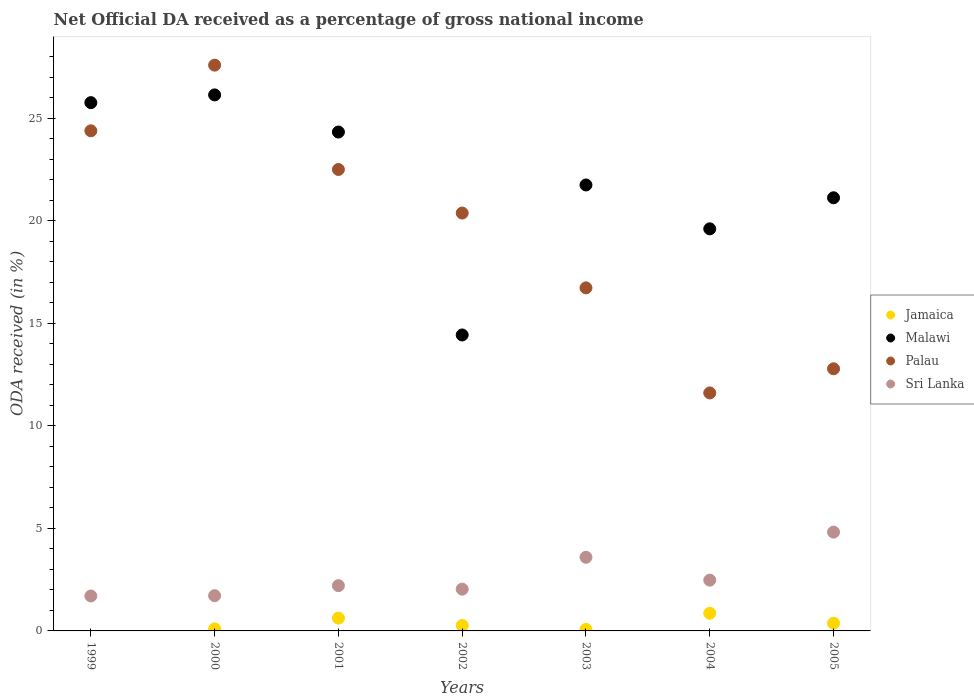How many different coloured dotlines are there?
Offer a terse response. 4. What is the net official DA received in Malawi in 2003?
Your answer should be compact. 21.74. Across all years, what is the maximum net official DA received in Palau?
Offer a very short reply. 27.58. Across all years, what is the minimum net official DA received in Malawi?
Offer a very short reply. 14.43. In which year was the net official DA received in Palau maximum?
Give a very brief answer. 2000. What is the total net official DA received in Palau in the graph?
Your answer should be very brief. 135.94. What is the difference between the net official DA received in Jamaica in 2000 and that in 2004?
Your answer should be compact. -0.76. What is the difference between the net official DA received in Sri Lanka in 2005 and the net official DA received in Palau in 2000?
Offer a very short reply. -22.77. What is the average net official DA received in Jamaica per year?
Your answer should be very brief. 0.33. In the year 2005, what is the difference between the net official DA received in Malawi and net official DA received in Palau?
Your answer should be compact. 8.34. In how many years, is the net official DA received in Jamaica greater than 27 %?
Keep it short and to the point. 0. What is the ratio of the net official DA received in Sri Lanka in 2002 to that in 2004?
Make the answer very short. 0.82. Is the net official DA received in Jamaica in 2001 less than that in 2003?
Make the answer very short. No. Is the difference between the net official DA received in Malawi in 2001 and 2003 greater than the difference between the net official DA received in Palau in 2001 and 2003?
Offer a very short reply. No. What is the difference between the highest and the second highest net official DA received in Palau?
Provide a succinct answer. 3.2. What is the difference between the highest and the lowest net official DA received in Palau?
Ensure brevity in your answer.  15.98. In how many years, is the net official DA received in Sri Lanka greater than the average net official DA received in Sri Lanka taken over all years?
Offer a very short reply. 2. Is it the case that in every year, the sum of the net official DA received in Malawi and net official DA received in Palau  is greater than the net official DA received in Jamaica?
Make the answer very short. Yes. What is the difference between two consecutive major ticks on the Y-axis?
Your response must be concise. 5. Does the graph contain any zero values?
Provide a succinct answer. Yes. Does the graph contain grids?
Give a very brief answer. No. How many legend labels are there?
Keep it short and to the point. 4. What is the title of the graph?
Offer a very short reply. Net Official DA received as a percentage of gross national income. What is the label or title of the Y-axis?
Offer a terse response. ODA received (in %). What is the ODA received (in %) in Malawi in 1999?
Your answer should be very brief. 25.75. What is the ODA received (in %) of Palau in 1999?
Give a very brief answer. 24.38. What is the ODA received (in %) of Sri Lanka in 1999?
Provide a succinct answer. 1.7. What is the ODA received (in %) in Jamaica in 2000?
Offer a terse response. 0.1. What is the ODA received (in %) of Malawi in 2000?
Give a very brief answer. 26.13. What is the ODA received (in %) in Palau in 2000?
Give a very brief answer. 27.58. What is the ODA received (in %) in Sri Lanka in 2000?
Offer a terse response. 1.72. What is the ODA received (in %) of Jamaica in 2001?
Your answer should be compact. 0.63. What is the ODA received (in %) of Malawi in 2001?
Keep it short and to the point. 24.32. What is the ODA received (in %) of Palau in 2001?
Your response must be concise. 22.5. What is the ODA received (in %) of Sri Lanka in 2001?
Make the answer very short. 2.21. What is the ODA received (in %) in Jamaica in 2002?
Your answer should be very brief. 0.26. What is the ODA received (in %) of Malawi in 2002?
Give a very brief answer. 14.43. What is the ODA received (in %) of Palau in 2002?
Offer a very short reply. 20.37. What is the ODA received (in %) of Sri Lanka in 2002?
Make the answer very short. 2.04. What is the ODA received (in %) in Jamaica in 2003?
Offer a very short reply. 0.07. What is the ODA received (in %) of Malawi in 2003?
Make the answer very short. 21.74. What is the ODA received (in %) in Palau in 2003?
Provide a short and direct response. 16.73. What is the ODA received (in %) of Sri Lanka in 2003?
Offer a terse response. 3.59. What is the ODA received (in %) of Jamaica in 2004?
Make the answer very short. 0.86. What is the ODA received (in %) in Malawi in 2004?
Your answer should be compact. 19.6. What is the ODA received (in %) in Palau in 2004?
Your answer should be compact. 11.6. What is the ODA received (in %) of Sri Lanka in 2004?
Make the answer very short. 2.48. What is the ODA received (in %) of Jamaica in 2005?
Keep it short and to the point. 0.38. What is the ODA received (in %) in Malawi in 2005?
Provide a short and direct response. 21.12. What is the ODA received (in %) in Palau in 2005?
Make the answer very short. 12.78. What is the ODA received (in %) in Sri Lanka in 2005?
Keep it short and to the point. 4.82. Across all years, what is the maximum ODA received (in %) in Jamaica?
Your answer should be compact. 0.86. Across all years, what is the maximum ODA received (in %) in Malawi?
Give a very brief answer. 26.13. Across all years, what is the maximum ODA received (in %) in Palau?
Your response must be concise. 27.58. Across all years, what is the maximum ODA received (in %) in Sri Lanka?
Offer a very short reply. 4.82. Across all years, what is the minimum ODA received (in %) of Malawi?
Make the answer very short. 14.43. Across all years, what is the minimum ODA received (in %) in Palau?
Keep it short and to the point. 11.6. Across all years, what is the minimum ODA received (in %) of Sri Lanka?
Provide a short and direct response. 1.7. What is the total ODA received (in %) in Jamaica in the graph?
Provide a short and direct response. 2.3. What is the total ODA received (in %) of Malawi in the graph?
Make the answer very short. 153.1. What is the total ODA received (in %) in Palau in the graph?
Your response must be concise. 135.94. What is the total ODA received (in %) in Sri Lanka in the graph?
Make the answer very short. 18.55. What is the difference between the ODA received (in %) of Malawi in 1999 and that in 2000?
Provide a short and direct response. -0.38. What is the difference between the ODA received (in %) of Palau in 1999 and that in 2000?
Provide a succinct answer. -3.2. What is the difference between the ODA received (in %) of Sri Lanka in 1999 and that in 2000?
Keep it short and to the point. -0.01. What is the difference between the ODA received (in %) of Malawi in 1999 and that in 2001?
Provide a short and direct response. 1.43. What is the difference between the ODA received (in %) of Palau in 1999 and that in 2001?
Your answer should be very brief. 1.89. What is the difference between the ODA received (in %) in Sri Lanka in 1999 and that in 2001?
Your answer should be very brief. -0.5. What is the difference between the ODA received (in %) of Malawi in 1999 and that in 2002?
Keep it short and to the point. 11.33. What is the difference between the ODA received (in %) in Palau in 1999 and that in 2002?
Give a very brief answer. 4.01. What is the difference between the ODA received (in %) of Sri Lanka in 1999 and that in 2002?
Ensure brevity in your answer.  -0.33. What is the difference between the ODA received (in %) of Malawi in 1999 and that in 2003?
Ensure brevity in your answer.  4.01. What is the difference between the ODA received (in %) in Palau in 1999 and that in 2003?
Your response must be concise. 7.66. What is the difference between the ODA received (in %) of Sri Lanka in 1999 and that in 2003?
Provide a succinct answer. -1.89. What is the difference between the ODA received (in %) of Malawi in 1999 and that in 2004?
Your answer should be compact. 6.15. What is the difference between the ODA received (in %) of Palau in 1999 and that in 2004?
Ensure brevity in your answer.  12.78. What is the difference between the ODA received (in %) in Sri Lanka in 1999 and that in 2004?
Your answer should be very brief. -0.77. What is the difference between the ODA received (in %) of Malawi in 1999 and that in 2005?
Ensure brevity in your answer.  4.64. What is the difference between the ODA received (in %) of Palau in 1999 and that in 2005?
Provide a succinct answer. 11.6. What is the difference between the ODA received (in %) of Sri Lanka in 1999 and that in 2005?
Your response must be concise. -3.11. What is the difference between the ODA received (in %) of Jamaica in 2000 and that in 2001?
Offer a very short reply. -0.53. What is the difference between the ODA received (in %) of Malawi in 2000 and that in 2001?
Provide a succinct answer. 1.81. What is the difference between the ODA received (in %) in Palau in 2000 and that in 2001?
Keep it short and to the point. 5.09. What is the difference between the ODA received (in %) of Sri Lanka in 2000 and that in 2001?
Offer a terse response. -0.49. What is the difference between the ODA received (in %) in Jamaica in 2000 and that in 2002?
Your response must be concise. -0.16. What is the difference between the ODA received (in %) in Malawi in 2000 and that in 2002?
Offer a very short reply. 11.7. What is the difference between the ODA received (in %) in Palau in 2000 and that in 2002?
Provide a succinct answer. 7.21. What is the difference between the ODA received (in %) in Sri Lanka in 2000 and that in 2002?
Offer a very short reply. -0.32. What is the difference between the ODA received (in %) in Jamaica in 2000 and that in 2003?
Your answer should be very brief. 0.03. What is the difference between the ODA received (in %) in Malawi in 2000 and that in 2003?
Your answer should be compact. 4.39. What is the difference between the ODA received (in %) in Palau in 2000 and that in 2003?
Your response must be concise. 10.86. What is the difference between the ODA received (in %) of Sri Lanka in 2000 and that in 2003?
Keep it short and to the point. -1.87. What is the difference between the ODA received (in %) of Jamaica in 2000 and that in 2004?
Offer a terse response. -0.76. What is the difference between the ODA received (in %) of Malawi in 2000 and that in 2004?
Make the answer very short. 6.53. What is the difference between the ODA received (in %) of Palau in 2000 and that in 2004?
Provide a succinct answer. 15.98. What is the difference between the ODA received (in %) of Sri Lanka in 2000 and that in 2004?
Your answer should be very brief. -0.76. What is the difference between the ODA received (in %) of Jamaica in 2000 and that in 2005?
Your answer should be compact. -0.28. What is the difference between the ODA received (in %) in Malawi in 2000 and that in 2005?
Provide a short and direct response. 5.02. What is the difference between the ODA received (in %) of Palau in 2000 and that in 2005?
Make the answer very short. 14.8. What is the difference between the ODA received (in %) of Sri Lanka in 2000 and that in 2005?
Ensure brevity in your answer.  -3.1. What is the difference between the ODA received (in %) in Jamaica in 2001 and that in 2002?
Ensure brevity in your answer.  0.36. What is the difference between the ODA received (in %) of Malawi in 2001 and that in 2002?
Provide a short and direct response. 9.89. What is the difference between the ODA received (in %) of Palau in 2001 and that in 2002?
Make the answer very short. 2.12. What is the difference between the ODA received (in %) of Sri Lanka in 2001 and that in 2002?
Offer a terse response. 0.17. What is the difference between the ODA received (in %) in Jamaica in 2001 and that in 2003?
Provide a short and direct response. 0.55. What is the difference between the ODA received (in %) of Malawi in 2001 and that in 2003?
Make the answer very short. 2.58. What is the difference between the ODA received (in %) in Palau in 2001 and that in 2003?
Your answer should be compact. 5.77. What is the difference between the ODA received (in %) in Sri Lanka in 2001 and that in 2003?
Offer a very short reply. -1.38. What is the difference between the ODA received (in %) in Jamaica in 2001 and that in 2004?
Your answer should be very brief. -0.24. What is the difference between the ODA received (in %) in Malawi in 2001 and that in 2004?
Give a very brief answer. 4.72. What is the difference between the ODA received (in %) of Palau in 2001 and that in 2004?
Give a very brief answer. 10.89. What is the difference between the ODA received (in %) of Sri Lanka in 2001 and that in 2004?
Offer a terse response. -0.27. What is the difference between the ODA received (in %) in Jamaica in 2001 and that in 2005?
Your answer should be compact. 0.25. What is the difference between the ODA received (in %) of Malawi in 2001 and that in 2005?
Keep it short and to the point. 3.21. What is the difference between the ODA received (in %) in Palau in 2001 and that in 2005?
Keep it short and to the point. 9.72. What is the difference between the ODA received (in %) in Sri Lanka in 2001 and that in 2005?
Your response must be concise. -2.61. What is the difference between the ODA received (in %) of Jamaica in 2002 and that in 2003?
Your response must be concise. 0.19. What is the difference between the ODA received (in %) of Malawi in 2002 and that in 2003?
Provide a succinct answer. -7.31. What is the difference between the ODA received (in %) in Palau in 2002 and that in 2003?
Offer a terse response. 3.65. What is the difference between the ODA received (in %) of Sri Lanka in 2002 and that in 2003?
Your answer should be very brief. -1.55. What is the difference between the ODA received (in %) in Jamaica in 2002 and that in 2004?
Provide a succinct answer. -0.6. What is the difference between the ODA received (in %) of Malawi in 2002 and that in 2004?
Make the answer very short. -5.17. What is the difference between the ODA received (in %) in Palau in 2002 and that in 2004?
Provide a short and direct response. 8.77. What is the difference between the ODA received (in %) in Sri Lanka in 2002 and that in 2004?
Provide a short and direct response. -0.44. What is the difference between the ODA received (in %) of Jamaica in 2002 and that in 2005?
Your answer should be very brief. -0.11. What is the difference between the ODA received (in %) in Malawi in 2002 and that in 2005?
Offer a very short reply. -6.69. What is the difference between the ODA received (in %) of Palau in 2002 and that in 2005?
Your response must be concise. 7.59. What is the difference between the ODA received (in %) of Sri Lanka in 2002 and that in 2005?
Your response must be concise. -2.78. What is the difference between the ODA received (in %) of Jamaica in 2003 and that in 2004?
Ensure brevity in your answer.  -0.79. What is the difference between the ODA received (in %) of Malawi in 2003 and that in 2004?
Your answer should be compact. 2.14. What is the difference between the ODA received (in %) in Palau in 2003 and that in 2004?
Make the answer very short. 5.12. What is the difference between the ODA received (in %) of Sri Lanka in 2003 and that in 2004?
Keep it short and to the point. 1.11. What is the difference between the ODA received (in %) in Jamaica in 2003 and that in 2005?
Provide a succinct answer. -0.3. What is the difference between the ODA received (in %) in Malawi in 2003 and that in 2005?
Your answer should be very brief. 0.62. What is the difference between the ODA received (in %) in Palau in 2003 and that in 2005?
Offer a very short reply. 3.95. What is the difference between the ODA received (in %) of Sri Lanka in 2003 and that in 2005?
Give a very brief answer. -1.23. What is the difference between the ODA received (in %) of Jamaica in 2004 and that in 2005?
Provide a short and direct response. 0.49. What is the difference between the ODA received (in %) in Malawi in 2004 and that in 2005?
Your response must be concise. -1.51. What is the difference between the ODA received (in %) in Palau in 2004 and that in 2005?
Your answer should be very brief. -1.18. What is the difference between the ODA received (in %) of Sri Lanka in 2004 and that in 2005?
Make the answer very short. -2.34. What is the difference between the ODA received (in %) in Malawi in 1999 and the ODA received (in %) in Palau in 2000?
Offer a very short reply. -1.83. What is the difference between the ODA received (in %) of Malawi in 1999 and the ODA received (in %) of Sri Lanka in 2000?
Your answer should be compact. 24.04. What is the difference between the ODA received (in %) in Palau in 1999 and the ODA received (in %) in Sri Lanka in 2000?
Keep it short and to the point. 22.66. What is the difference between the ODA received (in %) of Malawi in 1999 and the ODA received (in %) of Palau in 2001?
Provide a succinct answer. 3.26. What is the difference between the ODA received (in %) of Malawi in 1999 and the ODA received (in %) of Sri Lanka in 2001?
Your response must be concise. 23.55. What is the difference between the ODA received (in %) of Palau in 1999 and the ODA received (in %) of Sri Lanka in 2001?
Give a very brief answer. 22.17. What is the difference between the ODA received (in %) in Malawi in 1999 and the ODA received (in %) in Palau in 2002?
Offer a very short reply. 5.38. What is the difference between the ODA received (in %) of Malawi in 1999 and the ODA received (in %) of Sri Lanka in 2002?
Your answer should be compact. 23.72. What is the difference between the ODA received (in %) of Palau in 1999 and the ODA received (in %) of Sri Lanka in 2002?
Keep it short and to the point. 22.35. What is the difference between the ODA received (in %) in Malawi in 1999 and the ODA received (in %) in Palau in 2003?
Give a very brief answer. 9.03. What is the difference between the ODA received (in %) of Malawi in 1999 and the ODA received (in %) of Sri Lanka in 2003?
Offer a very short reply. 22.16. What is the difference between the ODA received (in %) in Palau in 1999 and the ODA received (in %) in Sri Lanka in 2003?
Ensure brevity in your answer.  20.79. What is the difference between the ODA received (in %) in Malawi in 1999 and the ODA received (in %) in Palau in 2004?
Make the answer very short. 14.15. What is the difference between the ODA received (in %) of Malawi in 1999 and the ODA received (in %) of Sri Lanka in 2004?
Your response must be concise. 23.28. What is the difference between the ODA received (in %) of Palau in 1999 and the ODA received (in %) of Sri Lanka in 2004?
Give a very brief answer. 21.91. What is the difference between the ODA received (in %) of Malawi in 1999 and the ODA received (in %) of Palau in 2005?
Offer a very short reply. 12.97. What is the difference between the ODA received (in %) of Malawi in 1999 and the ODA received (in %) of Sri Lanka in 2005?
Provide a short and direct response. 20.94. What is the difference between the ODA received (in %) in Palau in 1999 and the ODA received (in %) in Sri Lanka in 2005?
Give a very brief answer. 19.57. What is the difference between the ODA received (in %) in Jamaica in 2000 and the ODA received (in %) in Malawi in 2001?
Offer a very short reply. -24.22. What is the difference between the ODA received (in %) of Jamaica in 2000 and the ODA received (in %) of Palau in 2001?
Ensure brevity in your answer.  -22.4. What is the difference between the ODA received (in %) of Jamaica in 2000 and the ODA received (in %) of Sri Lanka in 2001?
Your response must be concise. -2.11. What is the difference between the ODA received (in %) of Malawi in 2000 and the ODA received (in %) of Palau in 2001?
Keep it short and to the point. 3.64. What is the difference between the ODA received (in %) of Malawi in 2000 and the ODA received (in %) of Sri Lanka in 2001?
Give a very brief answer. 23.92. What is the difference between the ODA received (in %) of Palau in 2000 and the ODA received (in %) of Sri Lanka in 2001?
Offer a very short reply. 25.38. What is the difference between the ODA received (in %) of Jamaica in 2000 and the ODA received (in %) of Malawi in 2002?
Keep it short and to the point. -14.33. What is the difference between the ODA received (in %) in Jamaica in 2000 and the ODA received (in %) in Palau in 2002?
Offer a terse response. -20.27. What is the difference between the ODA received (in %) in Jamaica in 2000 and the ODA received (in %) in Sri Lanka in 2002?
Provide a succinct answer. -1.94. What is the difference between the ODA received (in %) in Malawi in 2000 and the ODA received (in %) in Palau in 2002?
Provide a succinct answer. 5.76. What is the difference between the ODA received (in %) of Malawi in 2000 and the ODA received (in %) of Sri Lanka in 2002?
Provide a short and direct response. 24.1. What is the difference between the ODA received (in %) in Palau in 2000 and the ODA received (in %) in Sri Lanka in 2002?
Ensure brevity in your answer.  25.55. What is the difference between the ODA received (in %) of Jamaica in 2000 and the ODA received (in %) of Malawi in 2003?
Your answer should be very brief. -21.64. What is the difference between the ODA received (in %) in Jamaica in 2000 and the ODA received (in %) in Palau in 2003?
Give a very brief answer. -16.63. What is the difference between the ODA received (in %) of Jamaica in 2000 and the ODA received (in %) of Sri Lanka in 2003?
Provide a short and direct response. -3.49. What is the difference between the ODA received (in %) in Malawi in 2000 and the ODA received (in %) in Palau in 2003?
Provide a succinct answer. 9.41. What is the difference between the ODA received (in %) of Malawi in 2000 and the ODA received (in %) of Sri Lanka in 2003?
Give a very brief answer. 22.54. What is the difference between the ODA received (in %) of Palau in 2000 and the ODA received (in %) of Sri Lanka in 2003?
Provide a succinct answer. 23.99. What is the difference between the ODA received (in %) of Jamaica in 2000 and the ODA received (in %) of Malawi in 2004?
Ensure brevity in your answer.  -19.5. What is the difference between the ODA received (in %) in Jamaica in 2000 and the ODA received (in %) in Palau in 2004?
Give a very brief answer. -11.5. What is the difference between the ODA received (in %) in Jamaica in 2000 and the ODA received (in %) in Sri Lanka in 2004?
Offer a very short reply. -2.38. What is the difference between the ODA received (in %) of Malawi in 2000 and the ODA received (in %) of Palau in 2004?
Your answer should be very brief. 14.53. What is the difference between the ODA received (in %) of Malawi in 2000 and the ODA received (in %) of Sri Lanka in 2004?
Give a very brief answer. 23.66. What is the difference between the ODA received (in %) in Palau in 2000 and the ODA received (in %) in Sri Lanka in 2004?
Your answer should be very brief. 25.11. What is the difference between the ODA received (in %) of Jamaica in 2000 and the ODA received (in %) of Malawi in 2005?
Provide a succinct answer. -21.02. What is the difference between the ODA received (in %) in Jamaica in 2000 and the ODA received (in %) in Palau in 2005?
Make the answer very short. -12.68. What is the difference between the ODA received (in %) in Jamaica in 2000 and the ODA received (in %) in Sri Lanka in 2005?
Your response must be concise. -4.72. What is the difference between the ODA received (in %) of Malawi in 2000 and the ODA received (in %) of Palau in 2005?
Your response must be concise. 13.35. What is the difference between the ODA received (in %) of Malawi in 2000 and the ODA received (in %) of Sri Lanka in 2005?
Ensure brevity in your answer.  21.32. What is the difference between the ODA received (in %) in Palau in 2000 and the ODA received (in %) in Sri Lanka in 2005?
Ensure brevity in your answer.  22.77. What is the difference between the ODA received (in %) in Jamaica in 2001 and the ODA received (in %) in Malawi in 2002?
Offer a very short reply. -13.8. What is the difference between the ODA received (in %) in Jamaica in 2001 and the ODA received (in %) in Palau in 2002?
Provide a short and direct response. -19.75. What is the difference between the ODA received (in %) of Jamaica in 2001 and the ODA received (in %) of Sri Lanka in 2002?
Your answer should be very brief. -1.41. What is the difference between the ODA received (in %) of Malawi in 2001 and the ODA received (in %) of Palau in 2002?
Offer a terse response. 3.95. What is the difference between the ODA received (in %) of Malawi in 2001 and the ODA received (in %) of Sri Lanka in 2002?
Provide a short and direct response. 22.29. What is the difference between the ODA received (in %) of Palau in 2001 and the ODA received (in %) of Sri Lanka in 2002?
Make the answer very short. 20.46. What is the difference between the ODA received (in %) of Jamaica in 2001 and the ODA received (in %) of Malawi in 2003?
Keep it short and to the point. -21.12. What is the difference between the ODA received (in %) in Jamaica in 2001 and the ODA received (in %) in Palau in 2003?
Your answer should be compact. -16.1. What is the difference between the ODA received (in %) in Jamaica in 2001 and the ODA received (in %) in Sri Lanka in 2003?
Your answer should be very brief. -2.97. What is the difference between the ODA received (in %) in Malawi in 2001 and the ODA received (in %) in Palau in 2003?
Offer a very short reply. 7.6. What is the difference between the ODA received (in %) in Malawi in 2001 and the ODA received (in %) in Sri Lanka in 2003?
Your answer should be very brief. 20.73. What is the difference between the ODA received (in %) of Palau in 2001 and the ODA received (in %) of Sri Lanka in 2003?
Make the answer very short. 18.91. What is the difference between the ODA received (in %) in Jamaica in 2001 and the ODA received (in %) in Malawi in 2004?
Ensure brevity in your answer.  -18.98. What is the difference between the ODA received (in %) in Jamaica in 2001 and the ODA received (in %) in Palau in 2004?
Provide a succinct answer. -10.98. What is the difference between the ODA received (in %) in Jamaica in 2001 and the ODA received (in %) in Sri Lanka in 2004?
Your answer should be compact. -1.85. What is the difference between the ODA received (in %) of Malawi in 2001 and the ODA received (in %) of Palau in 2004?
Your response must be concise. 12.72. What is the difference between the ODA received (in %) in Malawi in 2001 and the ODA received (in %) in Sri Lanka in 2004?
Ensure brevity in your answer.  21.85. What is the difference between the ODA received (in %) of Palau in 2001 and the ODA received (in %) of Sri Lanka in 2004?
Provide a short and direct response. 20.02. What is the difference between the ODA received (in %) in Jamaica in 2001 and the ODA received (in %) in Malawi in 2005?
Make the answer very short. -20.49. What is the difference between the ODA received (in %) of Jamaica in 2001 and the ODA received (in %) of Palau in 2005?
Provide a short and direct response. -12.15. What is the difference between the ODA received (in %) of Jamaica in 2001 and the ODA received (in %) of Sri Lanka in 2005?
Your answer should be very brief. -4.19. What is the difference between the ODA received (in %) of Malawi in 2001 and the ODA received (in %) of Palau in 2005?
Keep it short and to the point. 11.54. What is the difference between the ODA received (in %) in Malawi in 2001 and the ODA received (in %) in Sri Lanka in 2005?
Offer a very short reply. 19.51. What is the difference between the ODA received (in %) of Palau in 2001 and the ODA received (in %) of Sri Lanka in 2005?
Offer a very short reply. 17.68. What is the difference between the ODA received (in %) in Jamaica in 2002 and the ODA received (in %) in Malawi in 2003?
Offer a very short reply. -21.48. What is the difference between the ODA received (in %) in Jamaica in 2002 and the ODA received (in %) in Palau in 2003?
Give a very brief answer. -16.46. What is the difference between the ODA received (in %) in Jamaica in 2002 and the ODA received (in %) in Sri Lanka in 2003?
Ensure brevity in your answer.  -3.33. What is the difference between the ODA received (in %) of Malawi in 2002 and the ODA received (in %) of Palau in 2003?
Offer a terse response. -2.3. What is the difference between the ODA received (in %) in Malawi in 2002 and the ODA received (in %) in Sri Lanka in 2003?
Offer a very short reply. 10.84. What is the difference between the ODA received (in %) in Palau in 2002 and the ODA received (in %) in Sri Lanka in 2003?
Offer a terse response. 16.78. What is the difference between the ODA received (in %) of Jamaica in 2002 and the ODA received (in %) of Malawi in 2004?
Your answer should be very brief. -19.34. What is the difference between the ODA received (in %) in Jamaica in 2002 and the ODA received (in %) in Palau in 2004?
Offer a very short reply. -11.34. What is the difference between the ODA received (in %) in Jamaica in 2002 and the ODA received (in %) in Sri Lanka in 2004?
Your answer should be very brief. -2.21. What is the difference between the ODA received (in %) of Malawi in 2002 and the ODA received (in %) of Palau in 2004?
Make the answer very short. 2.83. What is the difference between the ODA received (in %) of Malawi in 2002 and the ODA received (in %) of Sri Lanka in 2004?
Provide a short and direct response. 11.95. What is the difference between the ODA received (in %) in Palau in 2002 and the ODA received (in %) in Sri Lanka in 2004?
Give a very brief answer. 17.9. What is the difference between the ODA received (in %) of Jamaica in 2002 and the ODA received (in %) of Malawi in 2005?
Provide a short and direct response. -20.85. What is the difference between the ODA received (in %) of Jamaica in 2002 and the ODA received (in %) of Palau in 2005?
Provide a short and direct response. -12.52. What is the difference between the ODA received (in %) in Jamaica in 2002 and the ODA received (in %) in Sri Lanka in 2005?
Offer a terse response. -4.55. What is the difference between the ODA received (in %) in Malawi in 2002 and the ODA received (in %) in Palau in 2005?
Provide a succinct answer. 1.65. What is the difference between the ODA received (in %) in Malawi in 2002 and the ODA received (in %) in Sri Lanka in 2005?
Provide a short and direct response. 9.61. What is the difference between the ODA received (in %) in Palau in 2002 and the ODA received (in %) in Sri Lanka in 2005?
Provide a succinct answer. 15.56. What is the difference between the ODA received (in %) of Jamaica in 2003 and the ODA received (in %) of Malawi in 2004?
Offer a very short reply. -19.53. What is the difference between the ODA received (in %) of Jamaica in 2003 and the ODA received (in %) of Palau in 2004?
Keep it short and to the point. -11.53. What is the difference between the ODA received (in %) in Jamaica in 2003 and the ODA received (in %) in Sri Lanka in 2004?
Offer a terse response. -2.4. What is the difference between the ODA received (in %) of Malawi in 2003 and the ODA received (in %) of Palau in 2004?
Keep it short and to the point. 10.14. What is the difference between the ODA received (in %) in Malawi in 2003 and the ODA received (in %) in Sri Lanka in 2004?
Offer a terse response. 19.27. What is the difference between the ODA received (in %) in Palau in 2003 and the ODA received (in %) in Sri Lanka in 2004?
Offer a terse response. 14.25. What is the difference between the ODA received (in %) in Jamaica in 2003 and the ODA received (in %) in Malawi in 2005?
Make the answer very short. -21.04. What is the difference between the ODA received (in %) of Jamaica in 2003 and the ODA received (in %) of Palau in 2005?
Ensure brevity in your answer.  -12.71. What is the difference between the ODA received (in %) of Jamaica in 2003 and the ODA received (in %) of Sri Lanka in 2005?
Offer a terse response. -4.74. What is the difference between the ODA received (in %) in Malawi in 2003 and the ODA received (in %) in Palau in 2005?
Give a very brief answer. 8.96. What is the difference between the ODA received (in %) of Malawi in 2003 and the ODA received (in %) of Sri Lanka in 2005?
Ensure brevity in your answer.  16.92. What is the difference between the ODA received (in %) of Palau in 2003 and the ODA received (in %) of Sri Lanka in 2005?
Give a very brief answer. 11.91. What is the difference between the ODA received (in %) of Jamaica in 2004 and the ODA received (in %) of Malawi in 2005?
Provide a succinct answer. -20.25. What is the difference between the ODA received (in %) of Jamaica in 2004 and the ODA received (in %) of Palau in 2005?
Your answer should be compact. -11.92. What is the difference between the ODA received (in %) in Jamaica in 2004 and the ODA received (in %) in Sri Lanka in 2005?
Give a very brief answer. -3.95. What is the difference between the ODA received (in %) of Malawi in 2004 and the ODA received (in %) of Palau in 2005?
Your response must be concise. 6.82. What is the difference between the ODA received (in %) in Malawi in 2004 and the ODA received (in %) in Sri Lanka in 2005?
Your answer should be compact. 14.79. What is the difference between the ODA received (in %) of Palau in 2004 and the ODA received (in %) of Sri Lanka in 2005?
Provide a succinct answer. 6.79. What is the average ODA received (in %) of Jamaica per year?
Make the answer very short. 0.33. What is the average ODA received (in %) of Malawi per year?
Your answer should be very brief. 21.87. What is the average ODA received (in %) of Palau per year?
Offer a terse response. 19.42. What is the average ODA received (in %) of Sri Lanka per year?
Keep it short and to the point. 2.65. In the year 1999, what is the difference between the ODA received (in %) of Malawi and ODA received (in %) of Palau?
Ensure brevity in your answer.  1.37. In the year 1999, what is the difference between the ODA received (in %) in Malawi and ODA received (in %) in Sri Lanka?
Keep it short and to the point. 24.05. In the year 1999, what is the difference between the ODA received (in %) of Palau and ODA received (in %) of Sri Lanka?
Ensure brevity in your answer.  22.68. In the year 2000, what is the difference between the ODA received (in %) in Jamaica and ODA received (in %) in Malawi?
Keep it short and to the point. -26.03. In the year 2000, what is the difference between the ODA received (in %) of Jamaica and ODA received (in %) of Palau?
Ensure brevity in your answer.  -27.48. In the year 2000, what is the difference between the ODA received (in %) in Jamaica and ODA received (in %) in Sri Lanka?
Make the answer very short. -1.62. In the year 2000, what is the difference between the ODA received (in %) of Malawi and ODA received (in %) of Palau?
Your response must be concise. -1.45. In the year 2000, what is the difference between the ODA received (in %) of Malawi and ODA received (in %) of Sri Lanka?
Provide a short and direct response. 24.41. In the year 2000, what is the difference between the ODA received (in %) of Palau and ODA received (in %) of Sri Lanka?
Your answer should be compact. 25.86. In the year 2001, what is the difference between the ODA received (in %) of Jamaica and ODA received (in %) of Malawi?
Your answer should be very brief. -23.7. In the year 2001, what is the difference between the ODA received (in %) in Jamaica and ODA received (in %) in Palau?
Ensure brevity in your answer.  -21.87. In the year 2001, what is the difference between the ODA received (in %) in Jamaica and ODA received (in %) in Sri Lanka?
Your answer should be very brief. -1.58. In the year 2001, what is the difference between the ODA received (in %) in Malawi and ODA received (in %) in Palau?
Offer a terse response. 1.83. In the year 2001, what is the difference between the ODA received (in %) in Malawi and ODA received (in %) in Sri Lanka?
Your answer should be compact. 22.11. In the year 2001, what is the difference between the ODA received (in %) in Palau and ODA received (in %) in Sri Lanka?
Keep it short and to the point. 20.29. In the year 2002, what is the difference between the ODA received (in %) of Jamaica and ODA received (in %) of Malawi?
Make the answer very short. -14.16. In the year 2002, what is the difference between the ODA received (in %) of Jamaica and ODA received (in %) of Palau?
Offer a terse response. -20.11. In the year 2002, what is the difference between the ODA received (in %) in Jamaica and ODA received (in %) in Sri Lanka?
Give a very brief answer. -1.77. In the year 2002, what is the difference between the ODA received (in %) of Malawi and ODA received (in %) of Palau?
Make the answer very short. -5.94. In the year 2002, what is the difference between the ODA received (in %) of Malawi and ODA received (in %) of Sri Lanka?
Your answer should be compact. 12.39. In the year 2002, what is the difference between the ODA received (in %) in Palau and ODA received (in %) in Sri Lanka?
Provide a succinct answer. 18.34. In the year 2003, what is the difference between the ODA received (in %) of Jamaica and ODA received (in %) of Malawi?
Give a very brief answer. -21.67. In the year 2003, what is the difference between the ODA received (in %) of Jamaica and ODA received (in %) of Palau?
Provide a succinct answer. -16.65. In the year 2003, what is the difference between the ODA received (in %) of Jamaica and ODA received (in %) of Sri Lanka?
Ensure brevity in your answer.  -3.52. In the year 2003, what is the difference between the ODA received (in %) of Malawi and ODA received (in %) of Palau?
Give a very brief answer. 5.02. In the year 2003, what is the difference between the ODA received (in %) of Malawi and ODA received (in %) of Sri Lanka?
Your answer should be very brief. 18.15. In the year 2003, what is the difference between the ODA received (in %) of Palau and ODA received (in %) of Sri Lanka?
Provide a short and direct response. 13.13. In the year 2004, what is the difference between the ODA received (in %) of Jamaica and ODA received (in %) of Malawi?
Ensure brevity in your answer.  -18.74. In the year 2004, what is the difference between the ODA received (in %) of Jamaica and ODA received (in %) of Palau?
Your answer should be compact. -10.74. In the year 2004, what is the difference between the ODA received (in %) in Jamaica and ODA received (in %) in Sri Lanka?
Your answer should be very brief. -1.61. In the year 2004, what is the difference between the ODA received (in %) of Malawi and ODA received (in %) of Sri Lanka?
Your answer should be compact. 17.13. In the year 2004, what is the difference between the ODA received (in %) of Palau and ODA received (in %) of Sri Lanka?
Offer a very short reply. 9.13. In the year 2005, what is the difference between the ODA received (in %) of Jamaica and ODA received (in %) of Malawi?
Provide a succinct answer. -20.74. In the year 2005, what is the difference between the ODA received (in %) in Jamaica and ODA received (in %) in Palau?
Offer a terse response. -12.4. In the year 2005, what is the difference between the ODA received (in %) of Jamaica and ODA received (in %) of Sri Lanka?
Your answer should be very brief. -4.44. In the year 2005, what is the difference between the ODA received (in %) in Malawi and ODA received (in %) in Palau?
Provide a succinct answer. 8.34. In the year 2005, what is the difference between the ODA received (in %) of Malawi and ODA received (in %) of Sri Lanka?
Provide a succinct answer. 16.3. In the year 2005, what is the difference between the ODA received (in %) in Palau and ODA received (in %) in Sri Lanka?
Offer a very short reply. 7.96. What is the ratio of the ODA received (in %) of Malawi in 1999 to that in 2000?
Keep it short and to the point. 0.99. What is the ratio of the ODA received (in %) of Palau in 1999 to that in 2000?
Give a very brief answer. 0.88. What is the ratio of the ODA received (in %) of Malawi in 1999 to that in 2001?
Give a very brief answer. 1.06. What is the ratio of the ODA received (in %) in Palau in 1999 to that in 2001?
Offer a very short reply. 1.08. What is the ratio of the ODA received (in %) in Sri Lanka in 1999 to that in 2001?
Your answer should be very brief. 0.77. What is the ratio of the ODA received (in %) of Malawi in 1999 to that in 2002?
Provide a succinct answer. 1.78. What is the ratio of the ODA received (in %) of Palau in 1999 to that in 2002?
Provide a short and direct response. 1.2. What is the ratio of the ODA received (in %) of Sri Lanka in 1999 to that in 2002?
Provide a succinct answer. 0.84. What is the ratio of the ODA received (in %) of Malawi in 1999 to that in 2003?
Make the answer very short. 1.18. What is the ratio of the ODA received (in %) of Palau in 1999 to that in 2003?
Provide a succinct answer. 1.46. What is the ratio of the ODA received (in %) in Sri Lanka in 1999 to that in 2003?
Offer a very short reply. 0.47. What is the ratio of the ODA received (in %) in Malawi in 1999 to that in 2004?
Keep it short and to the point. 1.31. What is the ratio of the ODA received (in %) of Palau in 1999 to that in 2004?
Make the answer very short. 2.1. What is the ratio of the ODA received (in %) in Sri Lanka in 1999 to that in 2004?
Make the answer very short. 0.69. What is the ratio of the ODA received (in %) of Malawi in 1999 to that in 2005?
Make the answer very short. 1.22. What is the ratio of the ODA received (in %) of Palau in 1999 to that in 2005?
Your answer should be very brief. 1.91. What is the ratio of the ODA received (in %) in Sri Lanka in 1999 to that in 2005?
Offer a terse response. 0.35. What is the ratio of the ODA received (in %) in Jamaica in 2000 to that in 2001?
Offer a very short reply. 0.16. What is the ratio of the ODA received (in %) of Malawi in 2000 to that in 2001?
Offer a terse response. 1.07. What is the ratio of the ODA received (in %) of Palau in 2000 to that in 2001?
Give a very brief answer. 1.23. What is the ratio of the ODA received (in %) of Sri Lanka in 2000 to that in 2001?
Offer a very short reply. 0.78. What is the ratio of the ODA received (in %) of Jamaica in 2000 to that in 2002?
Make the answer very short. 0.38. What is the ratio of the ODA received (in %) of Malawi in 2000 to that in 2002?
Provide a short and direct response. 1.81. What is the ratio of the ODA received (in %) of Palau in 2000 to that in 2002?
Keep it short and to the point. 1.35. What is the ratio of the ODA received (in %) of Sri Lanka in 2000 to that in 2002?
Provide a succinct answer. 0.84. What is the ratio of the ODA received (in %) of Jamaica in 2000 to that in 2003?
Offer a terse response. 1.35. What is the ratio of the ODA received (in %) of Malawi in 2000 to that in 2003?
Give a very brief answer. 1.2. What is the ratio of the ODA received (in %) of Palau in 2000 to that in 2003?
Your answer should be very brief. 1.65. What is the ratio of the ODA received (in %) of Sri Lanka in 2000 to that in 2003?
Your response must be concise. 0.48. What is the ratio of the ODA received (in %) in Jamaica in 2000 to that in 2004?
Give a very brief answer. 0.12. What is the ratio of the ODA received (in %) in Malawi in 2000 to that in 2004?
Provide a short and direct response. 1.33. What is the ratio of the ODA received (in %) of Palau in 2000 to that in 2004?
Offer a terse response. 2.38. What is the ratio of the ODA received (in %) in Sri Lanka in 2000 to that in 2004?
Keep it short and to the point. 0.69. What is the ratio of the ODA received (in %) of Jamaica in 2000 to that in 2005?
Offer a very short reply. 0.27. What is the ratio of the ODA received (in %) in Malawi in 2000 to that in 2005?
Provide a succinct answer. 1.24. What is the ratio of the ODA received (in %) in Palau in 2000 to that in 2005?
Your response must be concise. 2.16. What is the ratio of the ODA received (in %) in Sri Lanka in 2000 to that in 2005?
Your answer should be compact. 0.36. What is the ratio of the ODA received (in %) in Jamaica in 2001 to that in 2002?
Give a very brief answer. 2.37. What is the ratio of the ODA received (in %) of Malawi in 2001 to that in 2002?
Your answer should be very brief. 1.69. What is the ratio of the ODA received (in %) of Palau in 2001 to that in 2002?
Give a very brief answer. 1.1. What is the ratio of the ODA received (in %) of Sri Lanka in 2001 to that in 2002?
Provide a short and direct response. 1.08. What is the ratio of the ODA received (in %) of Jamaica in 2001 to that in 2003?
Offer a terse response. 8.48. What is the ratio of the ODA received (in %) in Malawi in 2001 to that in 2003?
Provide a short and direct response. 1.12. What is the ratio of the ODA received (in %) in Palau in 2001 to that in 2003?
Your answer should be compact. 1.35. What is the ratio of the ODA received (in %) in Sri Lanka in 2001 to that in 2003?
Keep it short and to the point. 0.61. What is the ratio of the ODA received (in %) in Jamaica in 2001 to that in 2004?
Offer a very short reply. 0.72. What is the ratio of the ODA received (in %) of Malawi in 2001 to that in 2004?
Provide a succinct answer. 1.24. What is the ratio of the ODA received (in %) in Palau in 2001 to that in 2004?
Ensure brevity in your answer.  1.94. What is the ratio of the ODA received (in %) in Sri Lanka in 2001 to that in 2004?
Provide a succinct answer. 0.89. What is the ratio of the ODA received (in %) in Jamaica in 2001 to that in 2005?
Make the answer very short. 1.66. What is the ratio of the ODA received (in %) of Malawi in 2001 to that in 2005?
Provide a short and direct response. 1.15. What is the ratio of the ODA received (in %) in Palau in 2001 to that in 2005?
Provide a succinct answer. 1.76. What is the ratio of the ODA received (in %) of Sri Lanka in 2001 to that in 2005?
Provide a short and direct response. 0.46. What is the ratio of the ODA received (in %) of Jamaica in 2002 to that in 2003?
Offer a terse response. 3.58. What is the ratio of the ODA received (in %) in Malawi in 2002 to that in 2003?
Keep it short and to the point. 0.66. What is the ratio of the ODA received (in %) of Palau in 2002 to that in 2003?
Your response must be concise. 1.22. What is the ratio of the ODA received (in %) of Sri Lanka in 2002 to that in 2003?
Offer a terse response. 0.57. What is the ratio of the ODA received (in %) in Jamaica in 2002 to that in 2004?
Offer a terse response. 0.31. What is the ratio of the ODA received (in %) of Malawi in 2002 to that in 2004?
Your response must be concise. 0.74. What is the ratio of the ODA received (in %) of Palau in 2002 to that in 2004?
Your response must be concise. 1.76. What is the ratio of the ODA received (in %) of Sri Lanka in 2002 to that in 2004?
Make the answer very short. 0.82. What is the ratio of the ODA received (in %) of Jamaica in 2002 to that in 2005?
Keep it short and to the point. 0.7. What is the ratio of the ODA received (in %) in Malawi in 2002 to that in 2005?
Keep it short and to the point. 0.68. What is the ratio of the ODA received (in %) of Palau in 2002 to that in 2005?
Give a very brief answer. 1.59. What is the ratio of the ODA received (in %) of Sri Lanka in 2002 to that in 2005?
Your response must be concise. 0.42. What is the ratio of the ODA received (in %) of Jamaica in 2003 to that in 2004?
Give a very brief answer. 0.09. What is the ratio of the ODA received (in %) of Malawi in 2003 to that in 2004?
Provide a short and direct response. 1.11. What is the ratio of the ODA received (in %) in Palau in 2003 to that in 2004?
Offer a very short reply. 1.44. What is the ratio of the ODA received (in %) of Sri Lanka in 2003 to that in 2004?
Provide a short and direct response. 1.45. What is the ratio of the ODA received (in %) of Jamaica in 2003 to that in 2005?
Keep it short and to the point. 0.2. What is the ratio of the ODA received (in %) in Malawi in 2003 to that in 2005?
Your response must be concise. 1.03. What is the ratio of the ODA received (in %) in Palau in 2003 to that in 2005?
Keep it short and to the point. 1.31. What is the ratio of the ODA received (in %) in Sri Lanka in 2003 to that in 2005?
Offer a very short reply. 0.75. What is the ratio of the ODA received (in %) in Jamaica in 2004 to that in 2005?
Provide a succinct answer. 2.3. What is the ratio of the ODA received (in %) in Malawi in 2004 to that in 2005?
Offer a terse response. 0.93. What is the ratio of the ODA received (in %) of Palau in 2004 to that in 2005?
Your response must be concise. 0.91. What is the ratio of the ODA received (in %) of Sri Lanka in 2004 to that in 2005?
Keep it short and to the point. 0.51. What is the difference between the highest and the second highest ODA received (in %) in Jamaica?
Offer a very short reply. 0.24. What is the difference between the highest and the second highest ODA received (in %) of Malawi?
Your answer should be very brief. 0.38. What is the difference between the highest and the second highest ODA received (in %) in Palau?
Provide a succinct answer. 3.2. What is the difference between the highest and the second highest ODA received (in %) in Sri Lanka?
Provide a short and direct response. 1.23. What is the difference between the highest and the lowest ODA received (in %) of Jamaica?
Your answer should be very brief. 0.86. What is the difference between the highest and the lowest ODA received (in %) of Malawi?
Your answer should be very brief. 11.7. What is the difference between the highest and the lowest ODA received (in %) in Palau?
Your response must be concise. 15.98. What is the difference between the highest and the lowest ODA received (in %) in Sri Lanka?
Give a very brief answer. 3.11. 